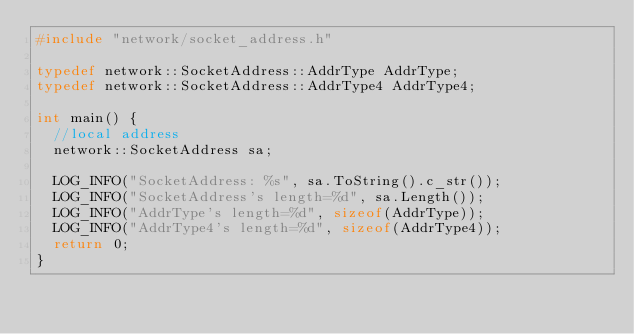Convert code to text. <code><loc_0><loc_0><loc_500><loc_500><_C++_>#include "network/socket_address.h"

typedef network::SocketAddress::AddrType AddrType;
typedef network::SocketAddress::AddrType4 AddrType4;

int main() {
  //local address
  network::SocketAddress sa;
  
  LOG_INFO("SocketAddress: %s", sa.ToString().c_str());
  LOG_INFO("SocketAddress's length=%d", sa.Length());
  LOG_INFO("AddrType's length=%d", sizeof(AddrType));
  LOG_INFO("AddrType4's length=%d", sizeof(AddrType4));
  return 0;		
}


</code> 